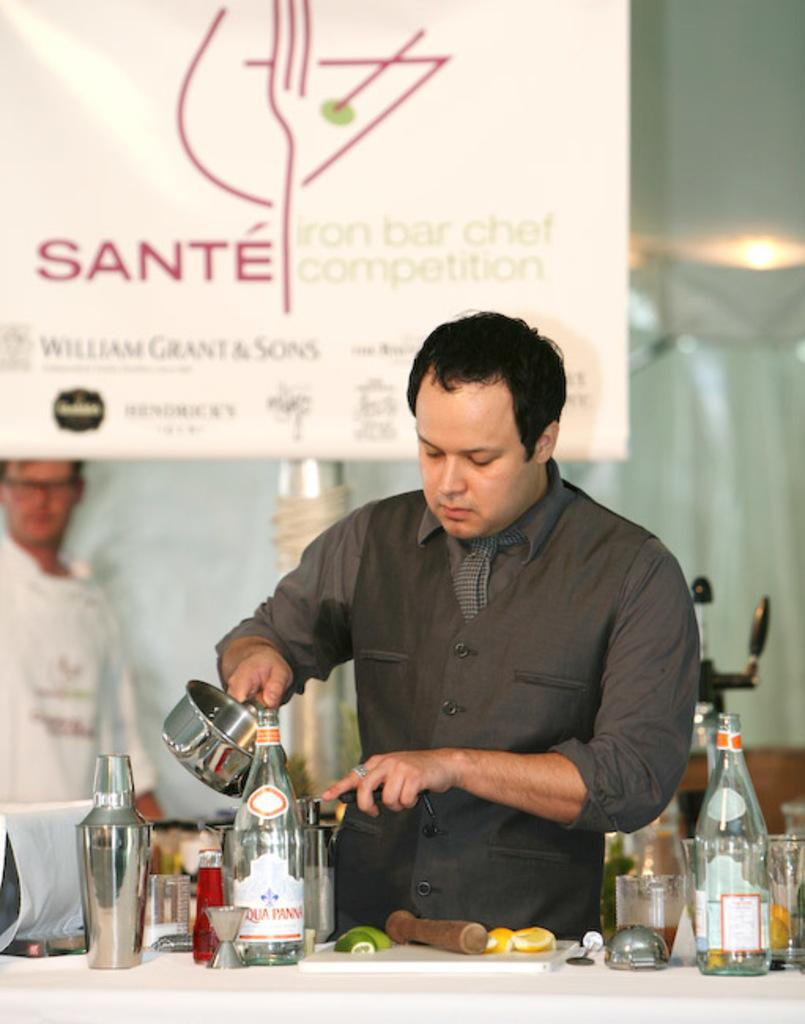<image>
Present a compact description of the photo's key features. A contestent at the Sante iron bar chef competition mixes ingredients. 